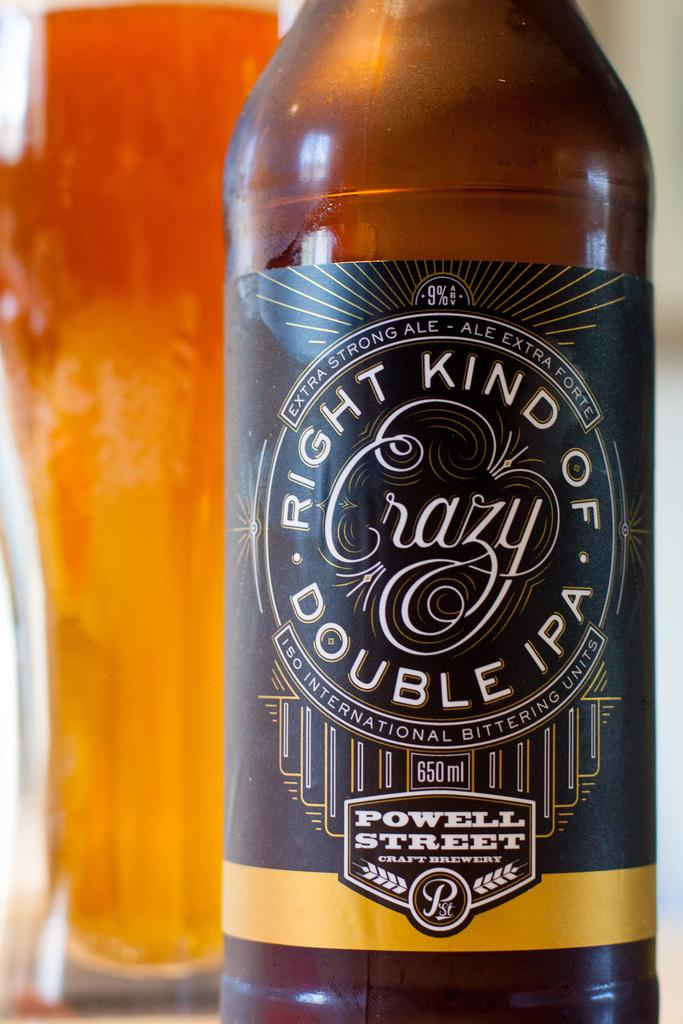<image>
Present a compact description of the photo's key features. Powell Street brewing made an IPA called Right Kind of Crazy 